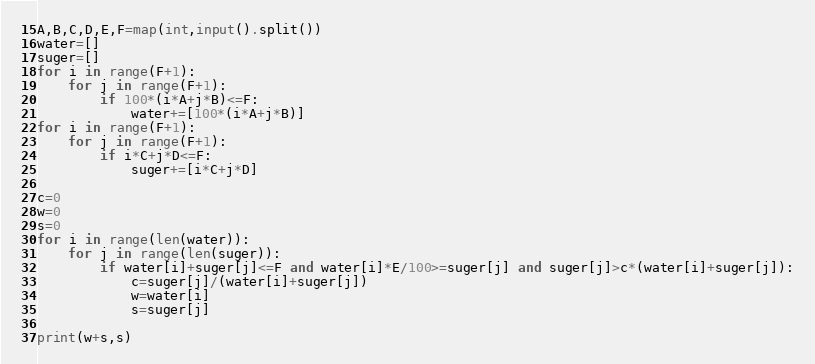<code> <loc_0><loc_0><loc_500><loc_500><_Python_>A,B,C,D,E,F=map(int,input().split())
water=[]
suger=[]
for i in range(F+1):
    for j in range(F+1):
        if 100*(i*A+j*B)<=F:
            water+=[100*(i*A+j*B)]
for i in range(F+1):
    for j in range(F+1):
        if i*C+j*D<=F:
            suger+=[i*C+j*D]

c=0
w=0
s=0
for i in range(len(water)):
    for j in range(len(suger)):
        if water[i]+suger[j]<=F and water[i]*E/100>=suger[j] and suger[j]>c*(water[i]+suger[j]):
            c=suger[j]/(water[i]+suger[j])
            w=water[i]
            s=suger[j]

print(w+s,s)
</code> 